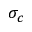Convert formula to latex. <formula><loc_0><loc_0><loc_500><loc_500>\sigma _ { c }</formula> 